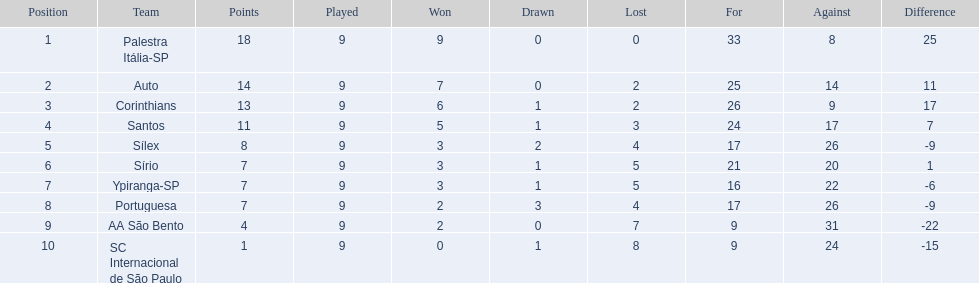Which is the only team to score 13 points in 9 games? Corinthians. 